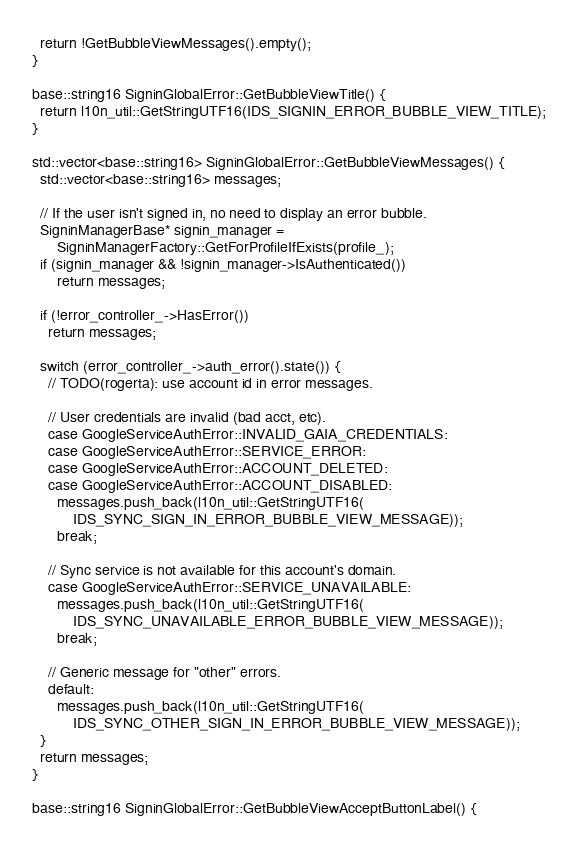<code> <loc_0><loc_0><loc_500><loc_500><_C++_>  return !GetBubbleViewMessages().empty();
}

base::string16 SigninGlobalError::GetBubbleViewTitle() {
  return l10n_util::GetStringUTF16(IDS_SIGNIN_ERROR_BUBBLE_VIEW_TITLE);
}

std::vector<base::string16> SigninGlobalError::GetBubbleViewMessages() {
  std::vector<base::string16> messages;

  // If the user isn't signed in, no need to display an error bubble.
  SigninManagerBase* signin_manager =
      SigninManagerFactory::GetForProfileIfExists(profile_);
  if (signin_manager && !signin_manager->IsAuthenticated())
      return messages;

  if (!error_controller_->HasError())
    return messages;

  switch (error_controller_->auth_error().state()) {
    // TODO(rogerta): use account id in error messages.

    // User credentials are invalid (bad acct, etc).
    case GoogleServiceAuthError::INVALID_GAIA_CREDENTIALS:
    case GoogleServiceAuthError::SERVICE_ERROR:
    case GoogleServiceAuthError::ACCOUNT_DELETED:
    case GoogleServiceAuthError::ACCOUNT_DISABLED:
      messages.push_back(l10n_util::GetStringUTF16(
          IDS_SYNC_SIGN_IN_ERROR_BUBBLE_VIEW_MESSAGE));
      break;

    // Sync service is not available for this account's domain.
    case GoogleServiceAuthError::SERVICE_UNAVAILABLE:
      messages.push_back(l10n_util::GetStringUTF16(
          IDS_SYNC_UNAVAILABLE_ERROR_BUBBLE_VIEW_MESSAGE));
      break;

    // Generic message for "other" errors.
    default:
      messages.push_back(l10n_util::GetStringUTF16(
          IDS_SYNC_OTHER_SIGN_IN_ERROR_BUBBLE_VIEW_MESSAGE));
  }
  return messages;
}

base::string16 SigninGlobalError::GetBubbleViewAcceptButtonLabel() {</code> 